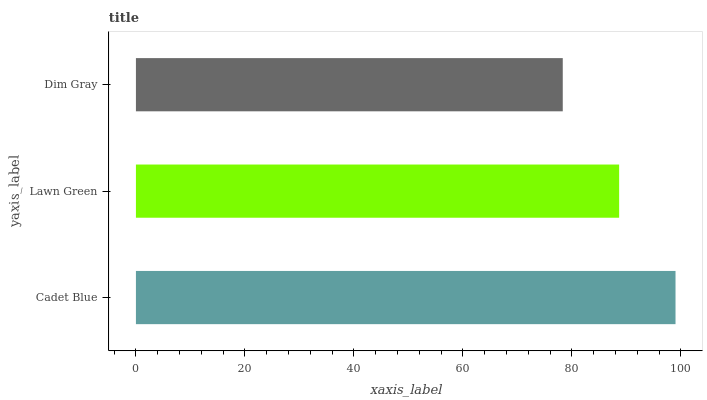Is Dim Gray the minimum?
Answer yes or no. Yes. Is Cadet Blue the maximum?
Answer yes or no. Yes. Is Lawn Green the minimum?
Answer yes or no. No. Is Lawn Green the maximum?
Answer yes or no. No. Is Cadet Blue greater than Lawn Green?
Answer yes or no. Yes. Is Lawn Green less than Cadet Blue?
Answer yes or no. Yes. Is Lawn Green greater than Cadet Blue?
Answer yes or no. No. Is Cadet Blue less than Lawn Green?
Answer yes or no. No. Is Lawn Green the high median?
Answer yes or no. Yes. Is Lawn Green the low median?
Answer yes or no. Yes. Is Dim Gray the high median?
Answer yes or no. No. Is Dim Gray the low median?
Answer yes or no. No. 